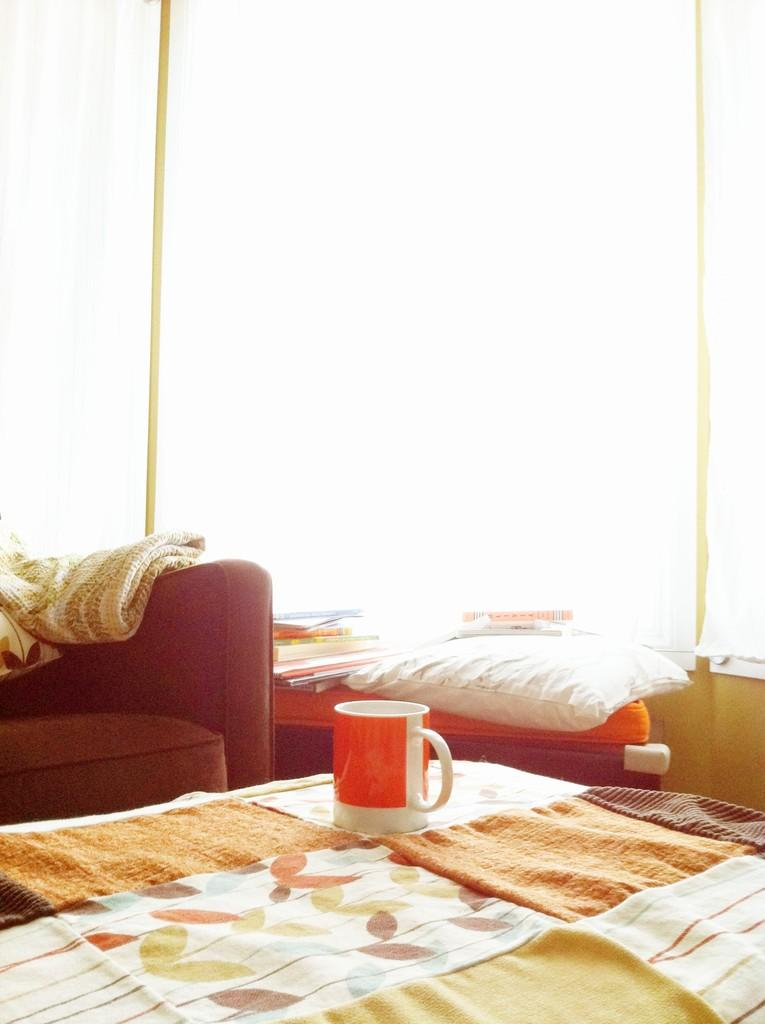What is placed on the bed in the image? There is a cup placed on a bed. What piece of furniture is beside the bed? There is a chair beside the bed. What items can be seen on the table in the image? There are books on a table. What type of window treatment is present in the image? There is a curtain present. What type of beetle can be seen crawling on the plate in the image? There is no plate or beetle present in the image. What is the temper of the person in the image? The image does not show a person, so it is not possible to determine their temper. 